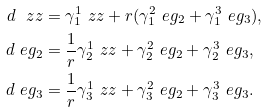Convert formula to latex. <formula><loc_0><loc_0><loc_500><loc_500>d \ z z & = \gamma ^ { 1 } _ { 1 } \ z z + r ( \gamma ^ { 2 } _ { 1 } \ e g _ { 2 } + \gamma ^ { 3 } _ { 1 } \ e g _ { 3 } ) , \\ d \ e g _ { 2 } & = \frac { 1 } { r } \gamma ^ { 1 } _ { 2 } \ z z + \gamma ^ { 2 } _ { 2 } \ e g _ { 2 } + \gamma ^ { 3 } _ { 2 } \ e g _ { 3 } , \\ d \ e g _ { 3 } & = \frac { 1 } { r } \gamma ^ { 1 } _ { 3 } \ z z + \gamma ^ { 2 } _ { 3 } \ e g _ { 2 } + \gamma ^ { 3 } _ { 3 } \ e g _ { 3 } .</formula> 